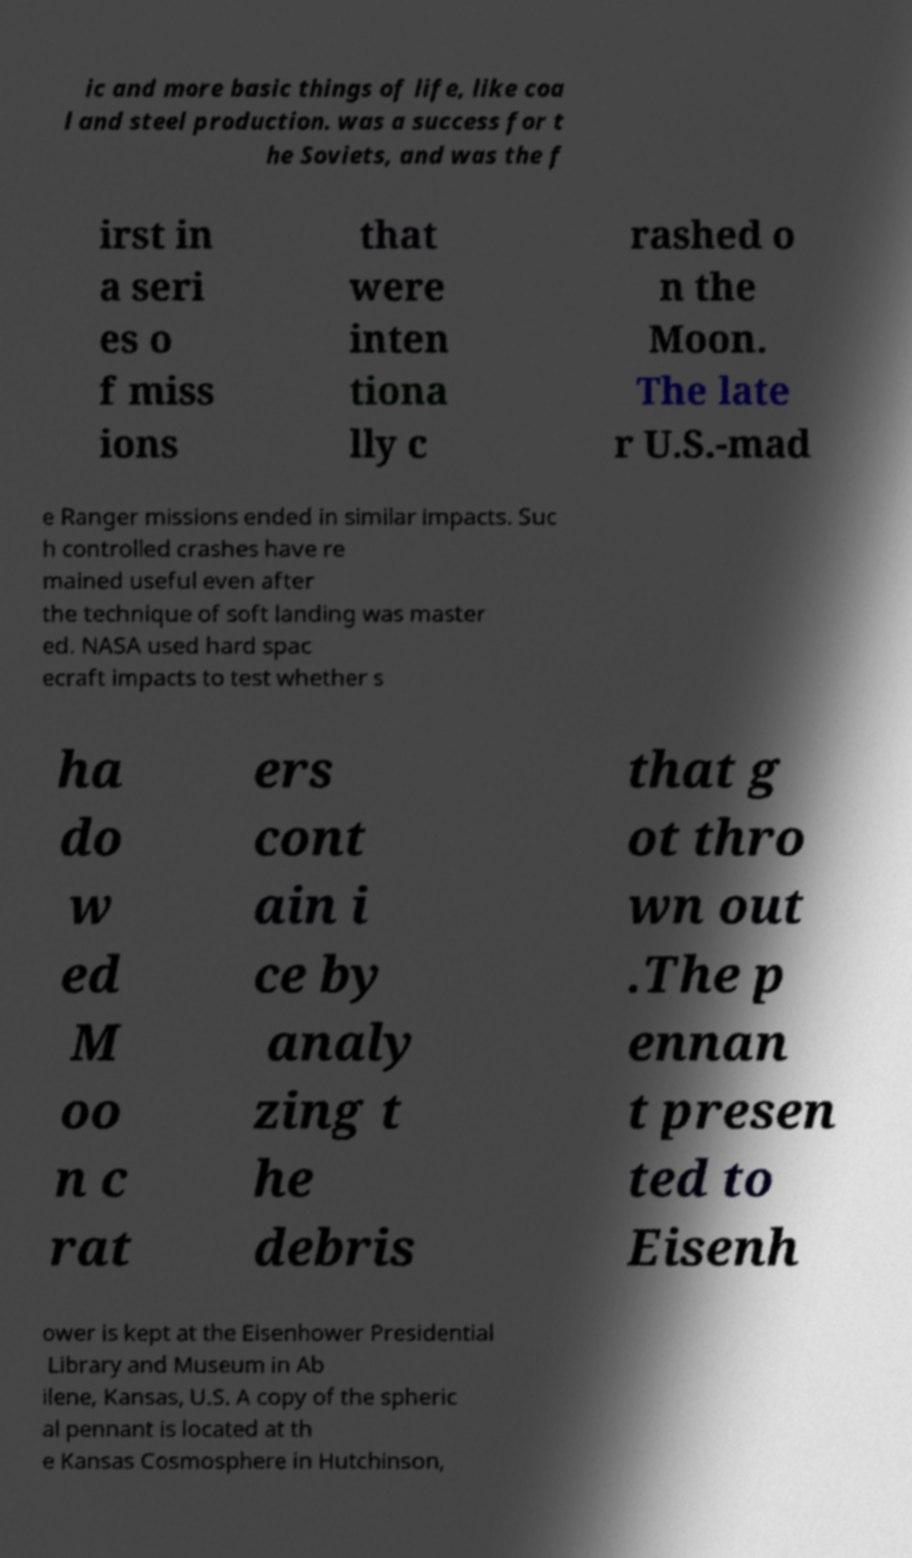Could you extract and type out the text from this image? ic and more basic things of life, like coa l and steel production. was a success for t he Soviets, and was the f irst in a seri es o f miss ions that were inten tiona lly c rashed o n the Moon. The late r U.S.-mad e Ranger missions ended in similar impacts. Suc h controlled crashes have re mained useful even after the technique of soft landing was master ed. NASA used hard spac ecraft impacts to test whether s ha do w ed M oo n c rat ers cont ain i ce by analy zing t he debris that g ot thro wn out .The p ennan t presen ted to Eisenh ower is kept at the Eisenhower Presidential Library and Museum in Ab ilene, Kansas, U.S. A copy of the spheric al pennant is located at th e Kansas Cosmosphere in Hutchinson, 